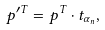Convert formula to latex. <formula><loc_0><loc_0><loc_500><loc_500>p ^ { \prime T } = p ^ { T } \cdot t _ { \alpha _ { n } } ,</formula> 